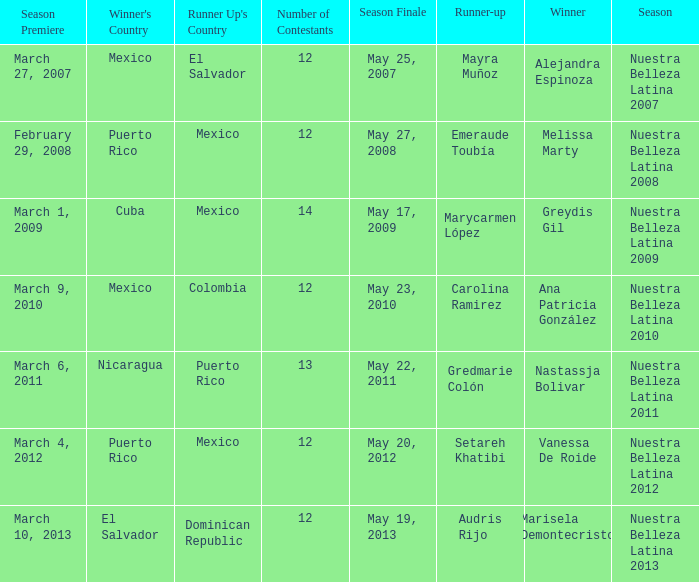How many contestants were there on March 1, 2009 during the season premiere? 14.0. 